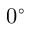Convert formula to latex. <formula><loc_0><loc_0><loc_500><loc_500>0 ^ { \circ }</formula> 